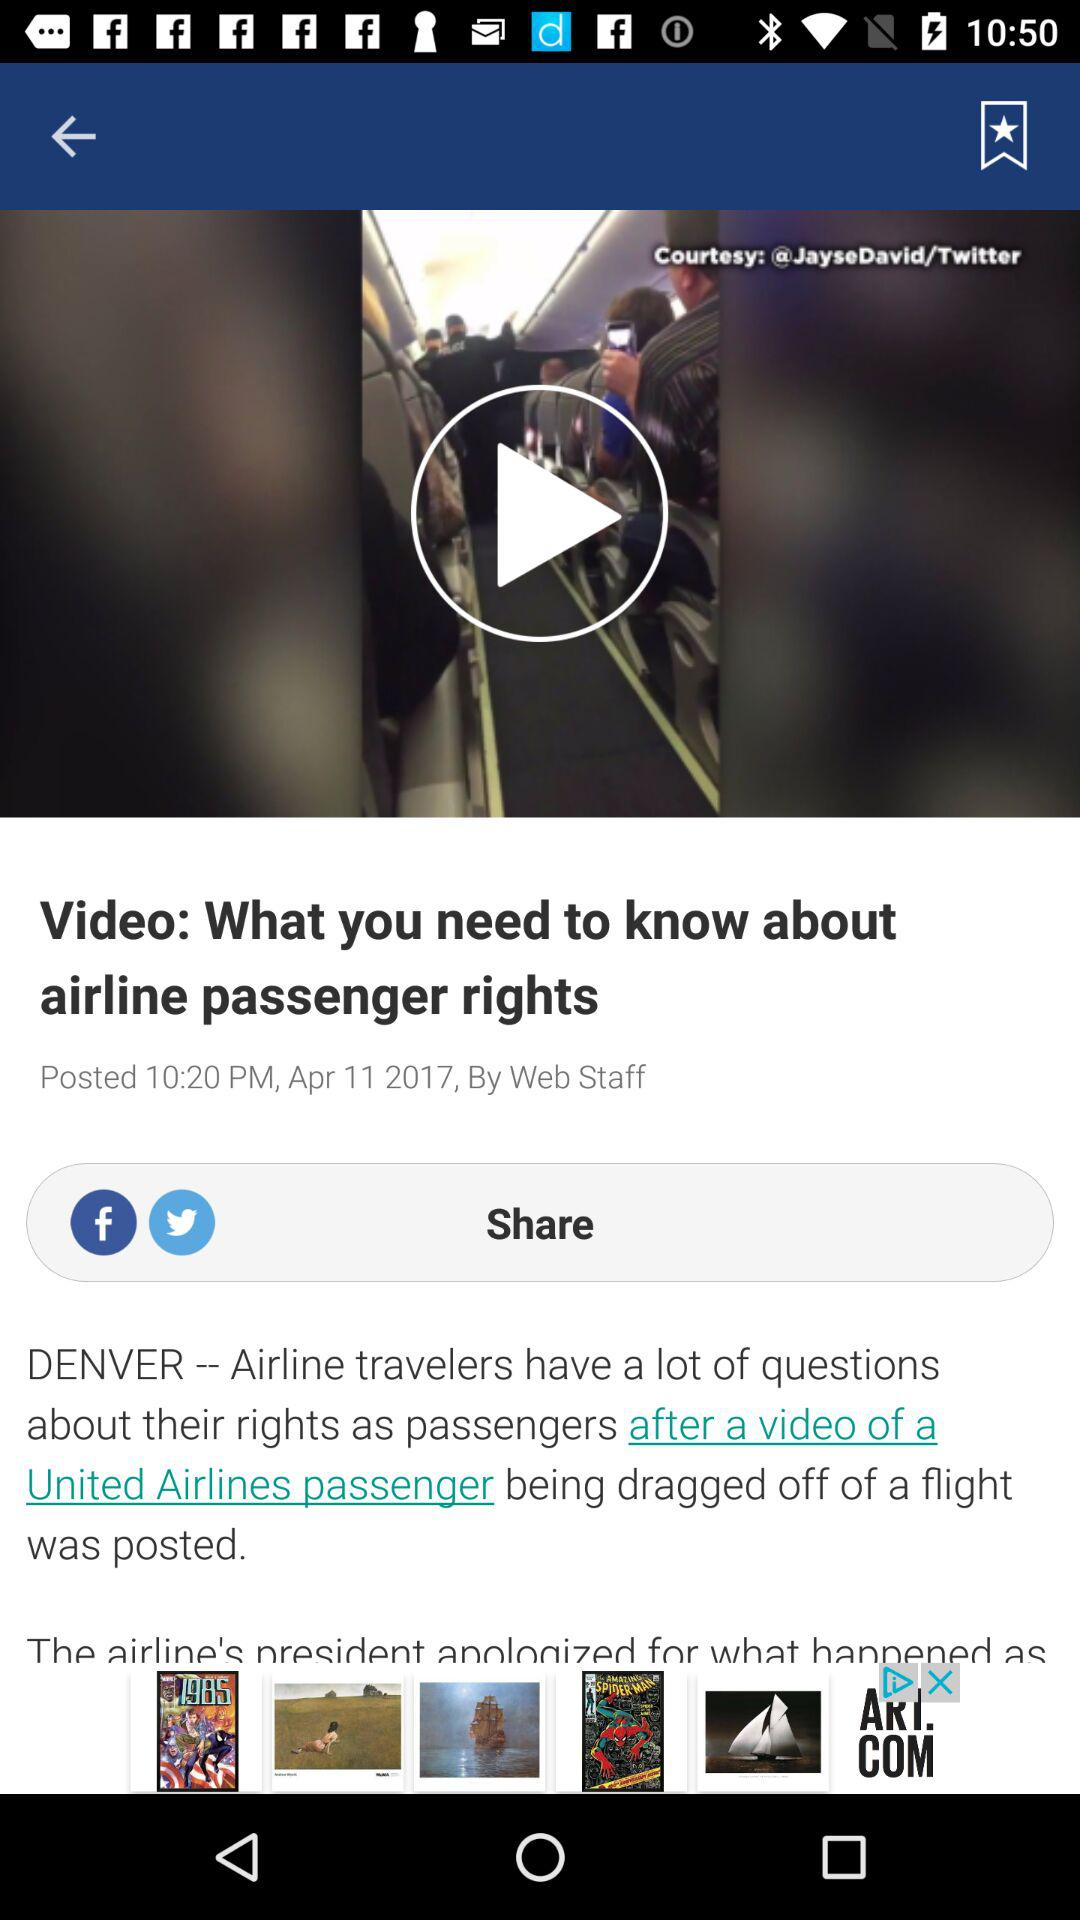What time was the article posted? The article was posted at 10:20 PM. 